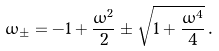<formula> <loc_0><loc_0><loc_500><loc_500>\omega _ { \pm } = - 1 + \frac { \omega ^ { 2 } } { 2 } \pm \sqrt { 1 + \frac { \omega ^ { 4 } } { 4 } } \, .</formula> 